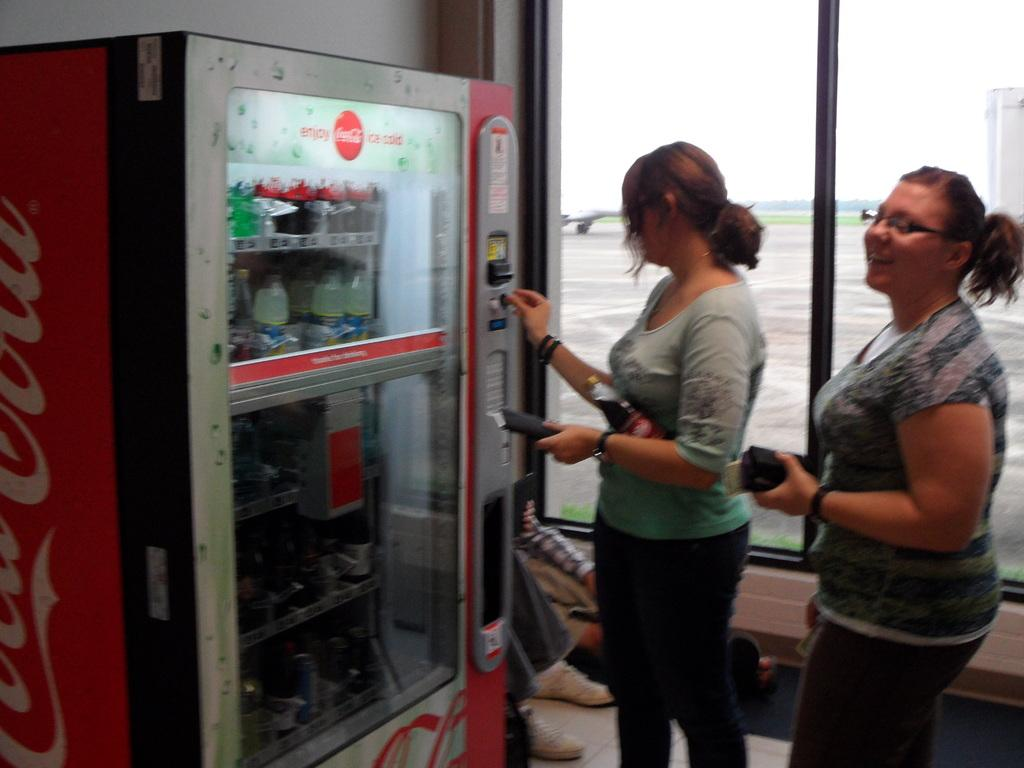Provide a one-sentence caption for the provided image. Two women standing at a coca-cola vending machine. 